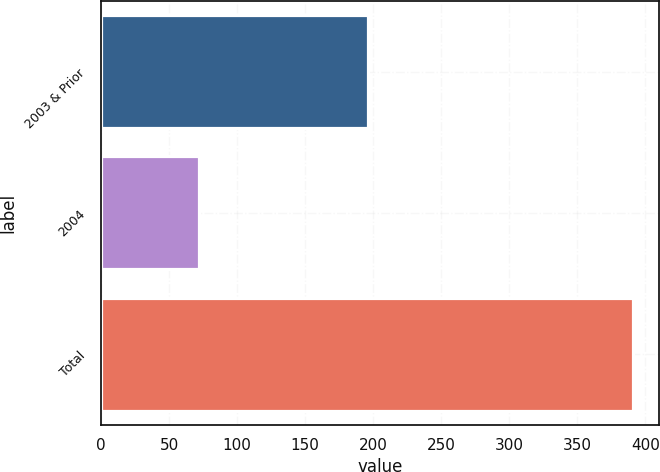Convert chart to OTSL. <chart><loc_0><loc_0><loc_500><loc_500><bar_chart><fcel>2003 & Prior<fcel>2004<fcel>Total<nl><fcel>196.2<fcel>71.7<fcel>390.8<nl></chart> 